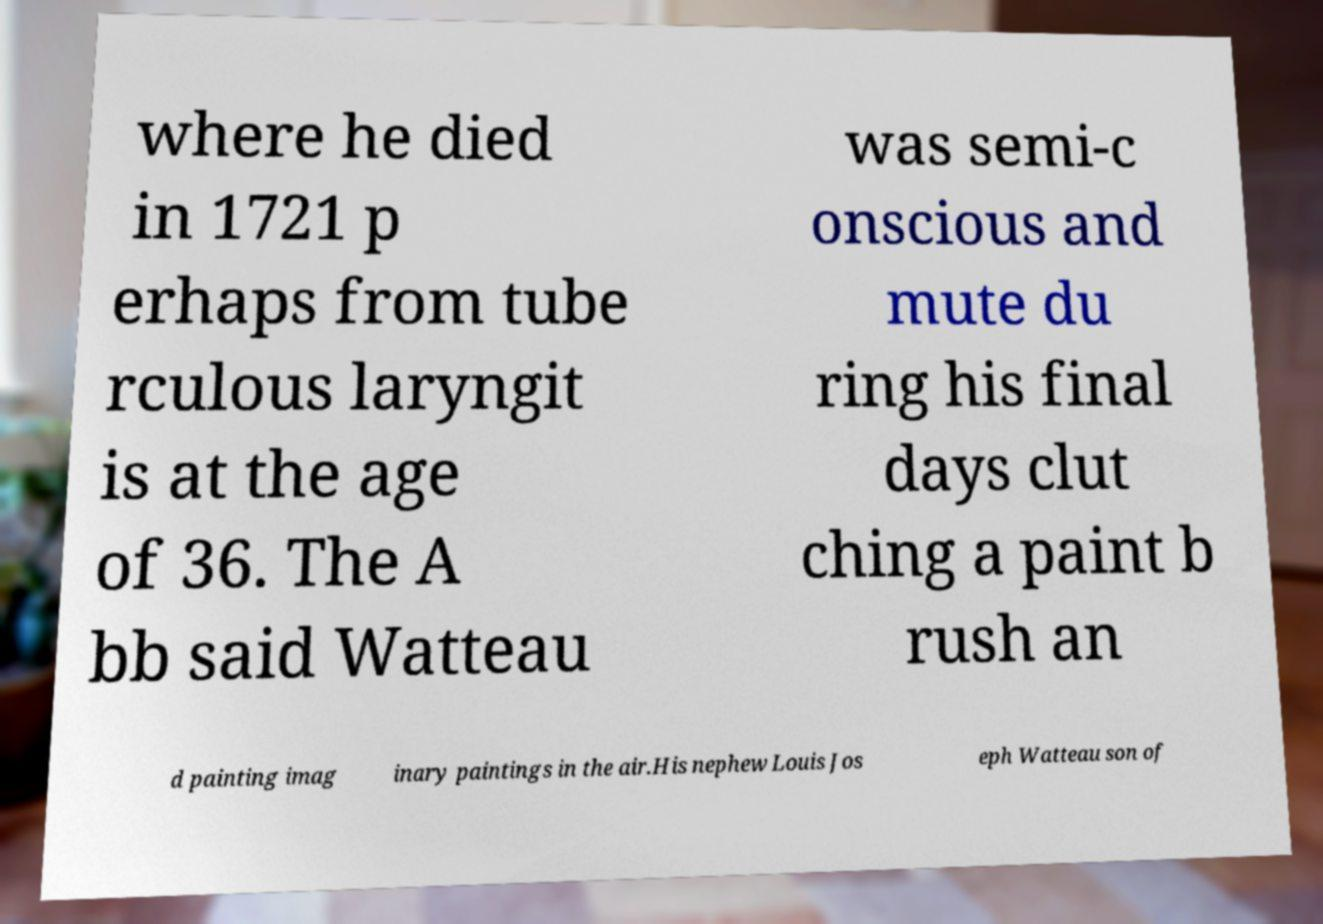Could you assist in decoding the text presented in this image and type it out clearly? where he died in 1721 p erhaps from tube rculous laryngit is at the age of 36. The A bb said Watteau was semi-c onscious and mute du ring his final days clut ching a paint b rush an d painting imag inary paintings in the air.His nephew Louis Jos eph Watteau son of 